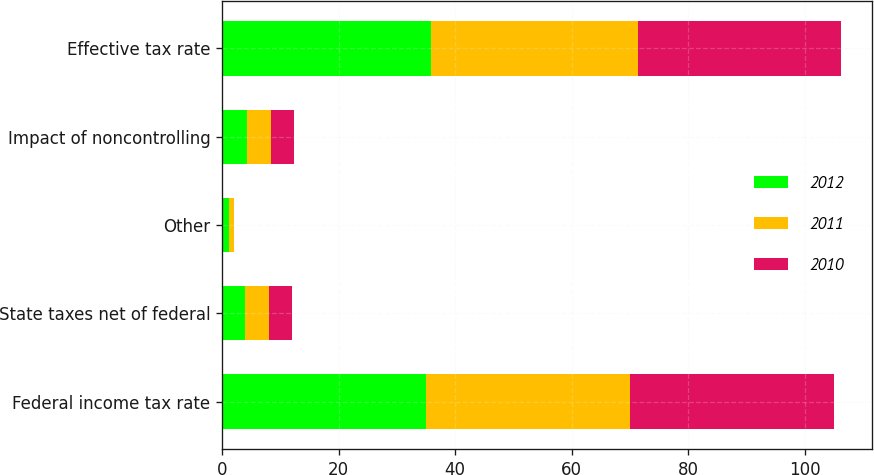Convert chart. <chart><loc_0><loc_0><loc_500><loc_500><stacked_bar_chart><ecel><fcel>Federal income tax rate<fcel>State taxes net of federal<fcel>Other<fcel>Impact of noncontrolling<fcel>Effective tax rate<nl><fcel>2012<fcel>35<fcel>4<fcel>1.1<fcel>4.2<fcel>35.9<nl><fcel>2011<fcel>35<fcel>4.1<fcel>0.9<fcel>4.2<fcel>35.5<nl><fcel>2010<fcel>35<fcel>3.9<fcel>0.1<fcel>4<fcel>34.9<nl></chart> 